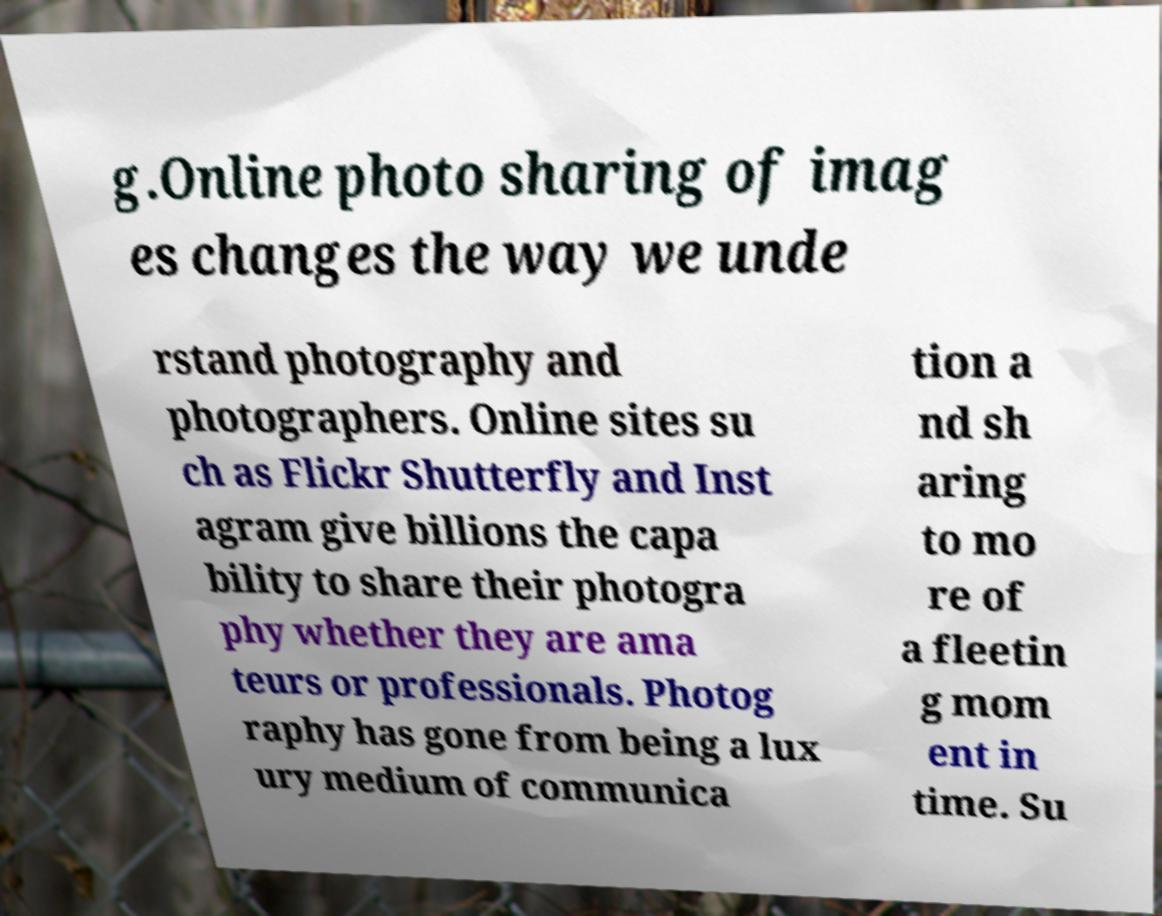Could you assist in decoding the text presented in this image and type it out clearly? g.Online photo sharing of imag es changes the way we unde rstand photography and photographers. Online sites su ch as Flickr Shutterfly and Inst agram give billions the capa bility to share their photogra phy whether they are ama teurs or professionals. Photog raphy has gone from being a lux ury medium of communica tion a nd sh aring to mo re of a fleetin g mom ent in time. Su 